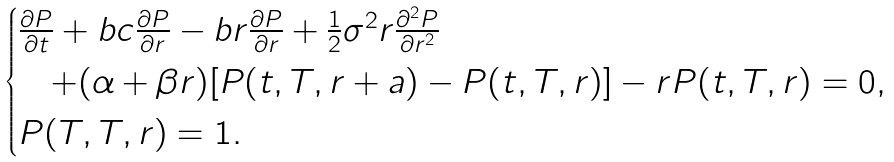Convert formula to latex. <formula><loc_0><loc_0><loc_500><loc_500>\begin{cases} \frac { \partial P } { \partial t } + b c \frac { \partial P } { \partial r } - b r \frac { \partial P } { \partial r } + \frac { 1 } { 2 } \sigma ^ { 2 } r \frac { \partial ^ { 2 } P } { \partial r ^ { 2 } } \\ \quad + ( \alpha + \beta r ) [ P ( t , T , r + a ) - P ( t , T , r ) ] - r P ( t , T , r ) = 0 , \\ P ( T , T , r ) = 1 . \end{cases}</formula> 